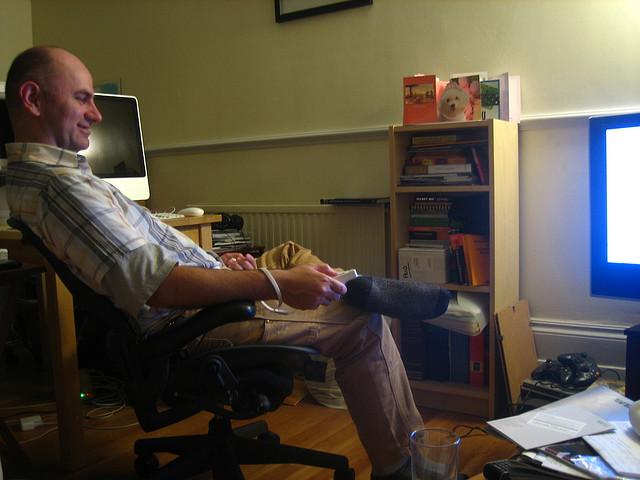Is the man smiling?
Give a very brief answer. Yes. What is this man doing?
Quick response, please. Playing wii. What is on the man's wrist?
Answer briefly. Bracelet. 